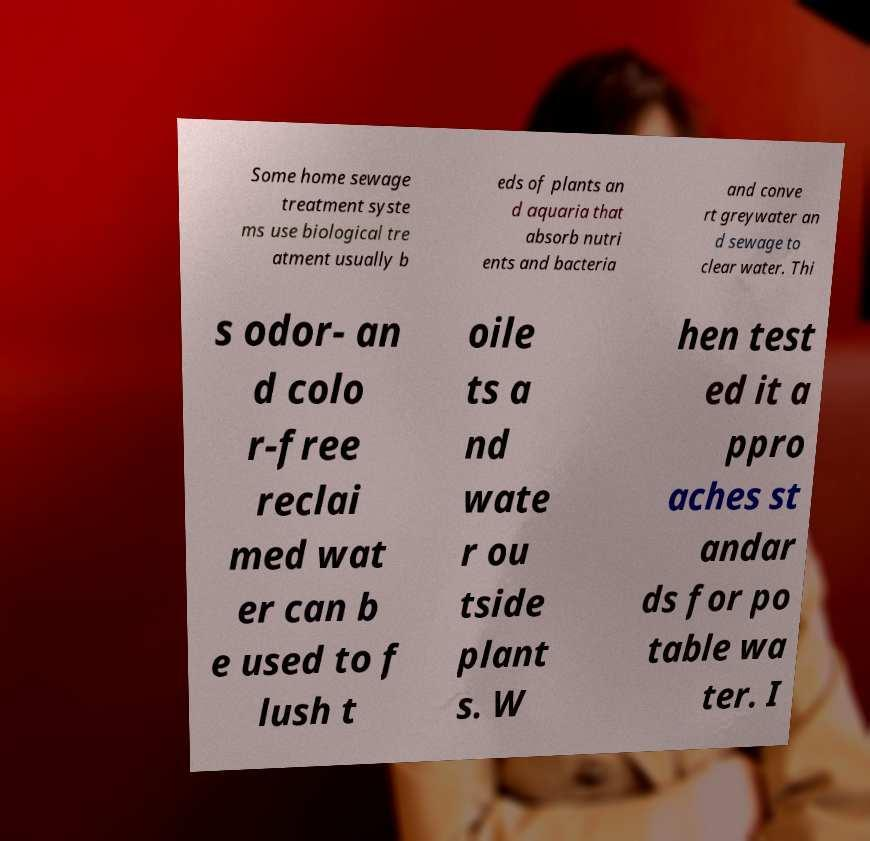Can you read and provide the text displayed in the image?This photo seems to have some interesting text. Can you extract and type it out for me? Some home sewage treatment syste ms use biological tre atment usually b eds of plants an d aquaria that absorb nutri ents and bacteria and conve rt greywater an d sewage to clear water. Thi s odor- an d colo r-free reclai med wat er can b e used to f lush t oile ts a nd wate r ou tside plant s. W hen test ed it a ppro aches st andar ds for po table wa ter. I 